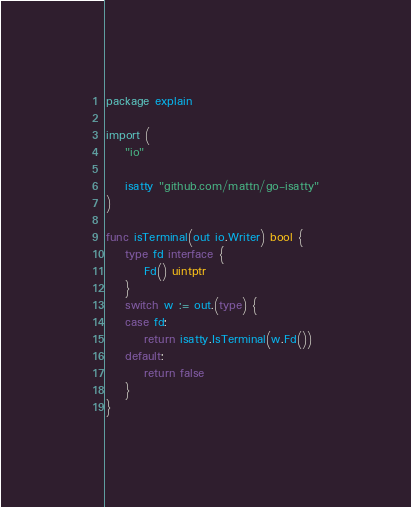<code> <loc_0><loc_0><loc_500><loc_500><_Go_>package explain

import (
	"io"

	isatty "github.com/mattn/go-isatty"
)

func isTerminal(out io.Writer) bool {
	type fd interface {
		Fd() uintptr
	}
	switch w := out.(type) {
	case fd:
		return isatty.IsTerminal(w.Fd())
	default:
		return false
	}
}
</code> 